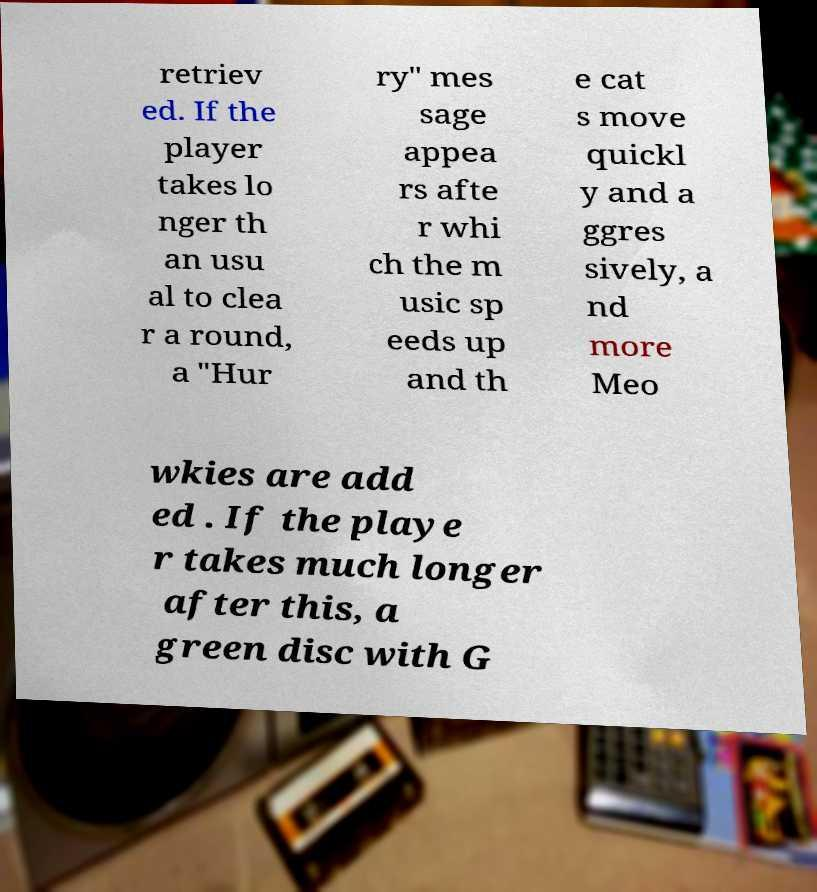I need the written content from this picture converted into text. Can you do that? retriev ed. If the player takes lo nger th an usu al to clea r a round, a "Hur ry" mes sage appea rs afte r whi ch the m usic sp eeds up and th e cat s move quickl y and a ggres sively, a nd more Meo wkies are add ed . If the playe r takes much longer after this, a green disc with G 